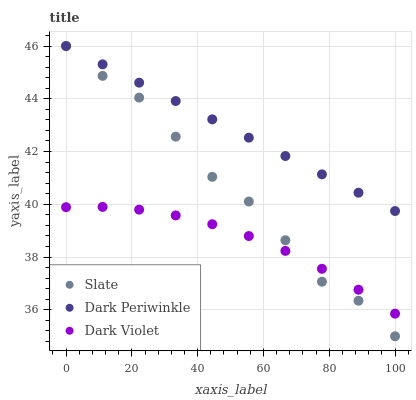Does Dark Violet have the minimum area under the curve?
Answer yes or no. Yes. Does Dark Periwinkle have the maximum area under the curve?
Answer yes or no. Yes. Does Dark Periwinkle have the minimum area under the curve?
Answer yes or no. No. Does Dark Violet have the maximum area under the curve?
Answer yes or no. No. Is Dark Periwinkle the smoothest?
Answer yes or no. Yes. Is Slate the roughest?
Answer yes or no. Yes. Is Dark Violet the smoothest?
Answer yes or no. No. Is Dark Violet the roughest?
Answer yes or no. No. Does Slate have the lowest value?
Answer yes or no. Yes. Does Dark Violet have the lowest value?
Answer yes or no. No. Does Dark Periwinkle have the highest value?
Answer yes or no. Yes. Does Dark Violet have the highest value?
Answer yes or no. No. Is Dark Violet less than Dark Periwinkle?
Answer yes or no. Yes. Is Dark Periwinkle greater than Dark Violet?
Answer yes or no. Yes. Does Slate intersect Dark Violet?
Answer yes or no. Yes. Is Slate less than Dark Violet?
Answer yes or no. No. Is Slate greater than Dark Violet?
Answer yes or no. No. Does Dark Violet intersect Dark Periwinkle?
Answer yes or no. No. 